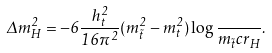<formula> <loc_0><loc_0><loc_500><loc_500>\Delta m _ { H } ^ { 2 } = - 6 \frac { h _ { t } ^ { 2 } } { 1 6 \pi ^ { 2 } } ( m _ { \tilde { t } } ^ { 2 } - m _ { t } ^ { 2 } ) \log \frac { } { m _ { \tilde { t } } c r _ { H } } .</formula> 